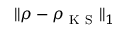<formula> <loc_0><loc_0><loc_500><loc_500>\| \rho - \rho _ { K S } \| _ { 1 }</formula> 